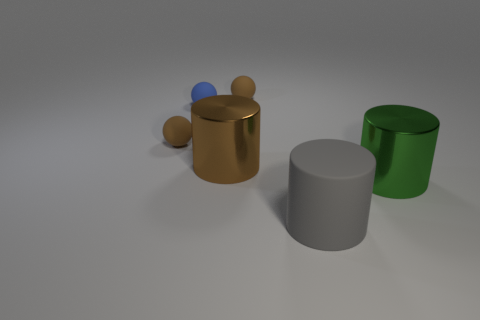Add 4 large brown metallic things. How many objects exist? 10 Add 2 big brown objects. How many big brown objects are left? 3 Add 2 brown metal cylinders. How many brown metal cylinders exist? 3 Subtract 0 purple balls. How many objects are left? 6 Subtract all tiny gray shiny spheres. Subtract all big gray things. How many objects are left? 5 